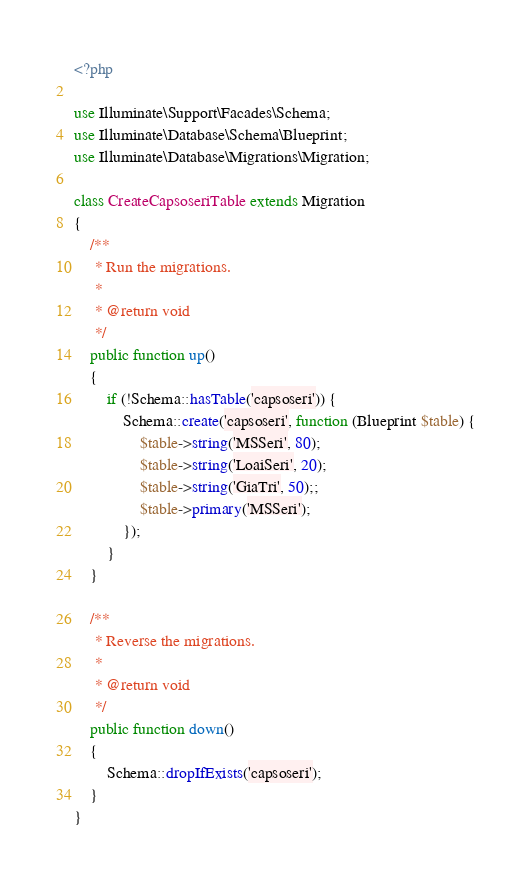Convert code to text. <code><loc_0><loc_0><loc_500><loc_500><_PHP_><?php

use Illuminate\Support\Facades\Schema;
use Illuminate\Database\Schema\Blueprint;
use Illuminate\Database\Migrations\Migration;

class CreateCapsoseriTable extends Migration
{
    /**
     * Run the migrations.
     *
     * @return void
     */
    public function up()
    {
        if (!Schema::hasTable('capsoseri')) {
            Schema::create('capsoseri', function (Blueprint $table) {
                $table->string('MSSeri', 80);
                $table->string('LoaiSeri', 20);
                $table->string('GiaTri', 50);;
                $table->primary('MSSeri');
            });
        }
    }

    /**
     * Reverse the migrations.
     *
     * @return void
     */
    public function down()
    {
        Schema::dropIfExists('capsoseri');
    }
}
</code> 